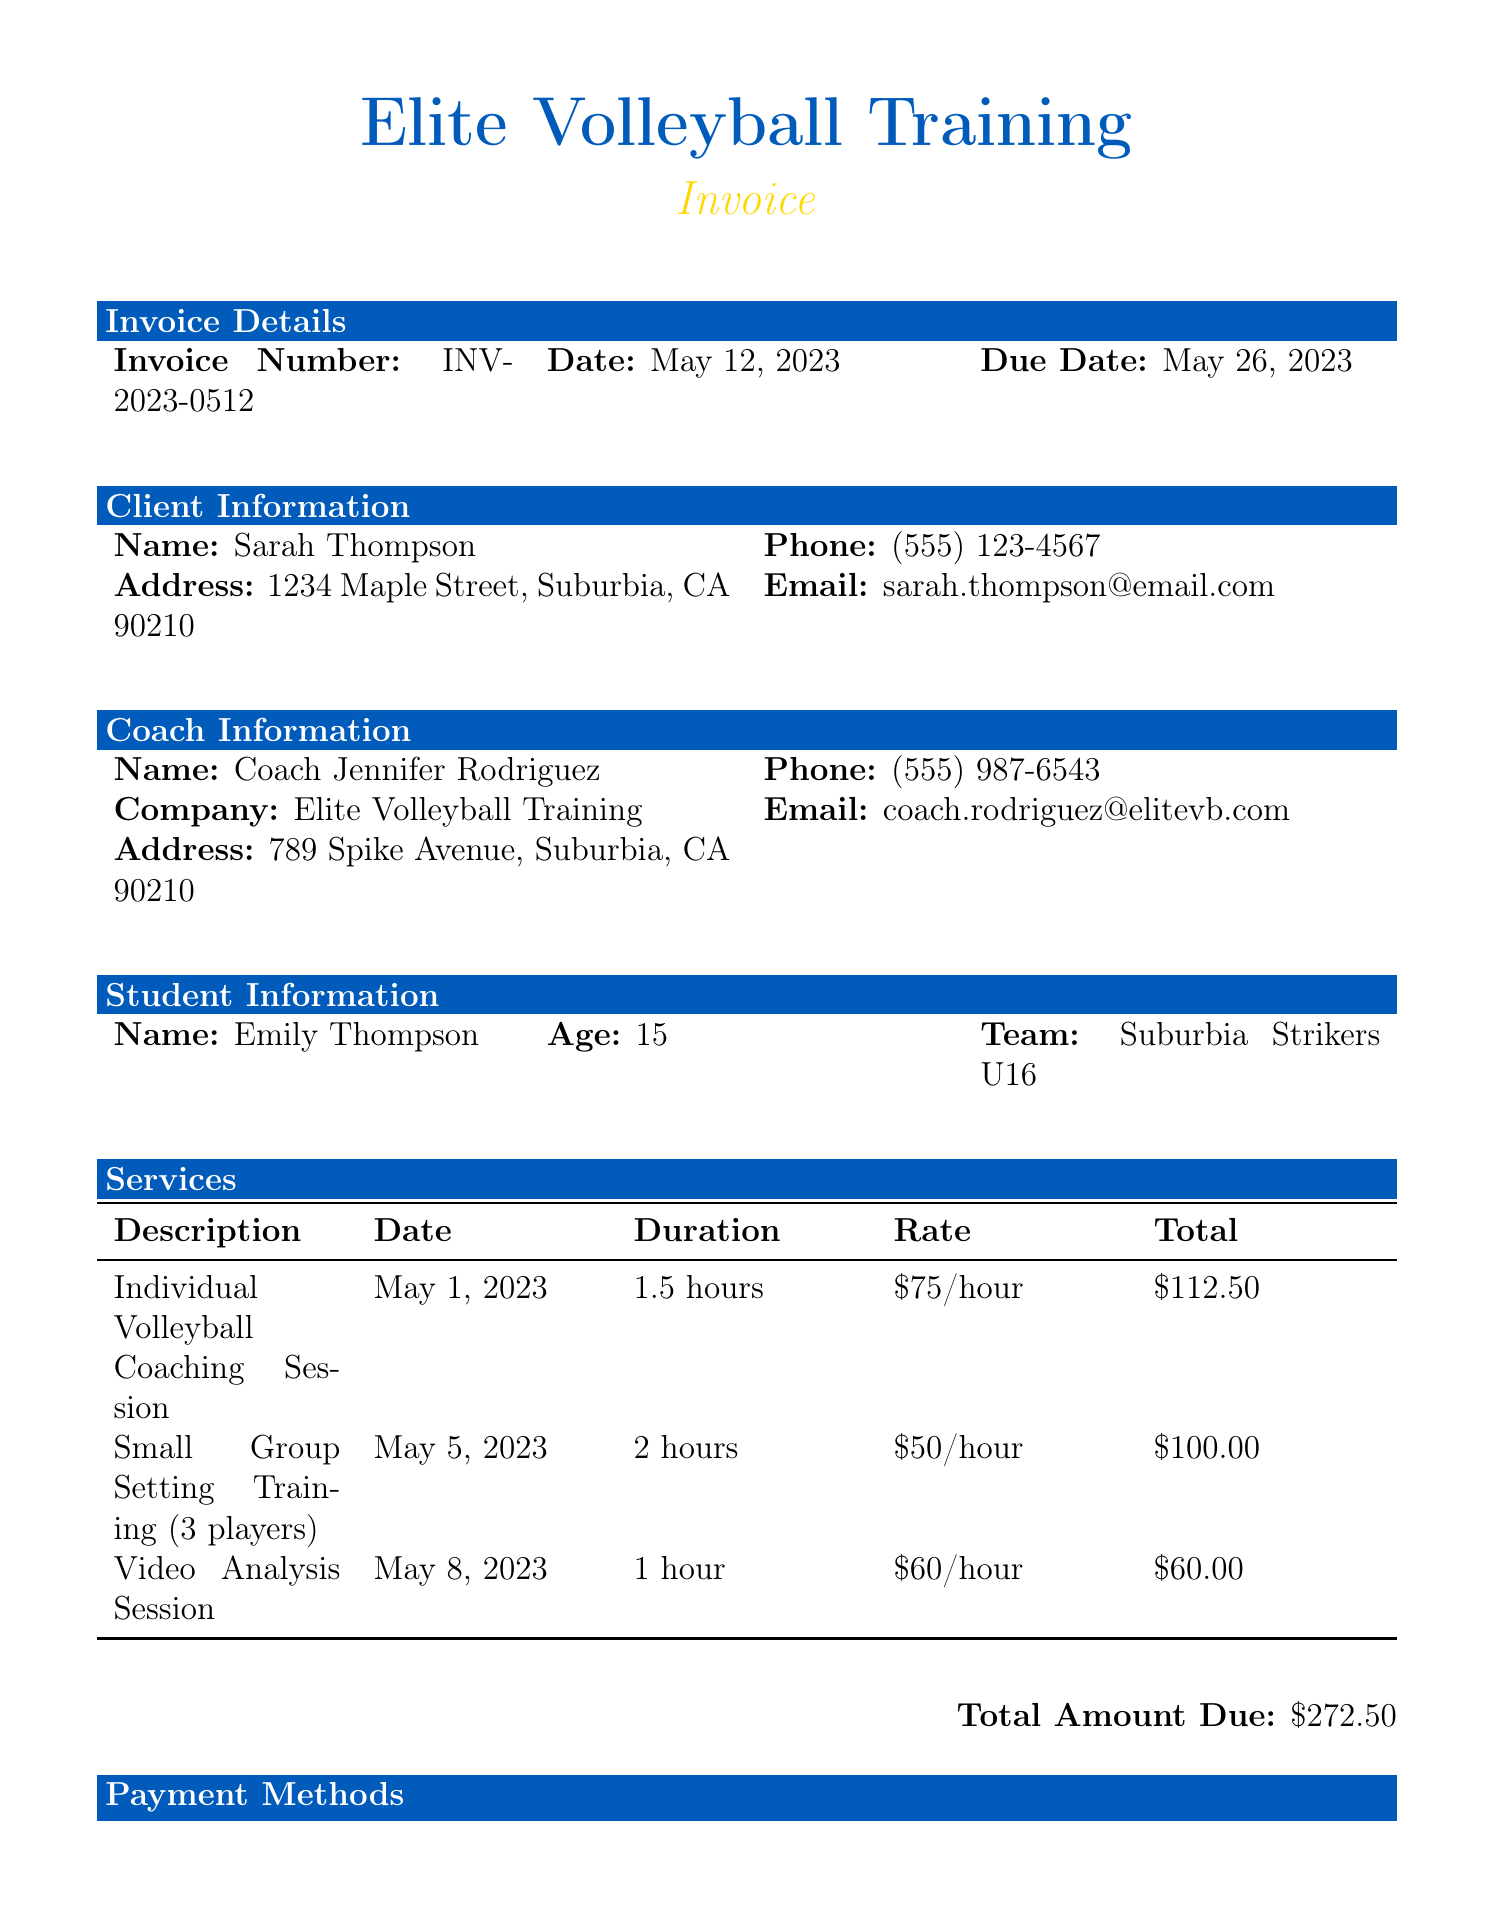What is the invoice number? The invoice number is a unique identifier for the invoice, listed in the document.
Answer: INV-2023-0512 Who is the coach? The coach's name is provided in the document, representing the individual providing the training.
Answer: Coach Jennifer Rodriguez What is the total amount due? The total amount due is the sum of the services listed in the invoice.
Answer: $272.50 What is the date of the next upcoming lesson? The upcoming lessons section lists several dates, highlighting the next scheduled lesson.
Answer: May 15, 2023 What cancellation notice is required? The document specifies the requirement for notifying about cancellations, which is a key part of the additional information.
Answer: 24-hour notice How many years of coaching experience does Coach Jennifer have? This information can be found in the coach qualifications section, indicating the level of experience.
Answer: 5 years What payment methods are accepted? The invoice outlines various ways to settle the payment, which is important for financial transactions.
Answer: Credit Card, Venmo (@EliteVB-Training), Check What is the focus of the session on May 22, 2023? Each lesson has a specific focus mentioned next to the date, which is important for preparation.
Answer: Offensive Strategies What is the location of the lessons? The location is specified in the additional information section, detailing where the lessons take place.
Answer: Suburbia Community Center, Court 3 